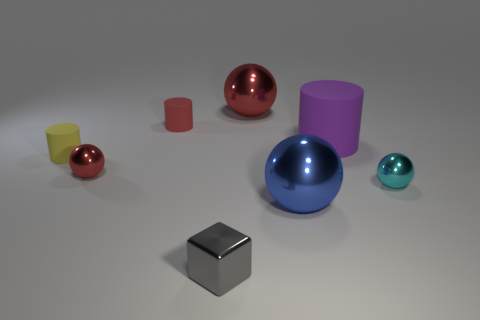Can you describe the colors and shapes of the objects in the image? Certainly! The image showcases a variety of geometric shapes in different colors. From left to right, there's a small yellow cylinder, a small red sphere, a large shiny red sphere, a large matte purple cylinder, a medium shiny blue sphere, and a small shiny teal sphere. At the front, there's a small gray cube. 